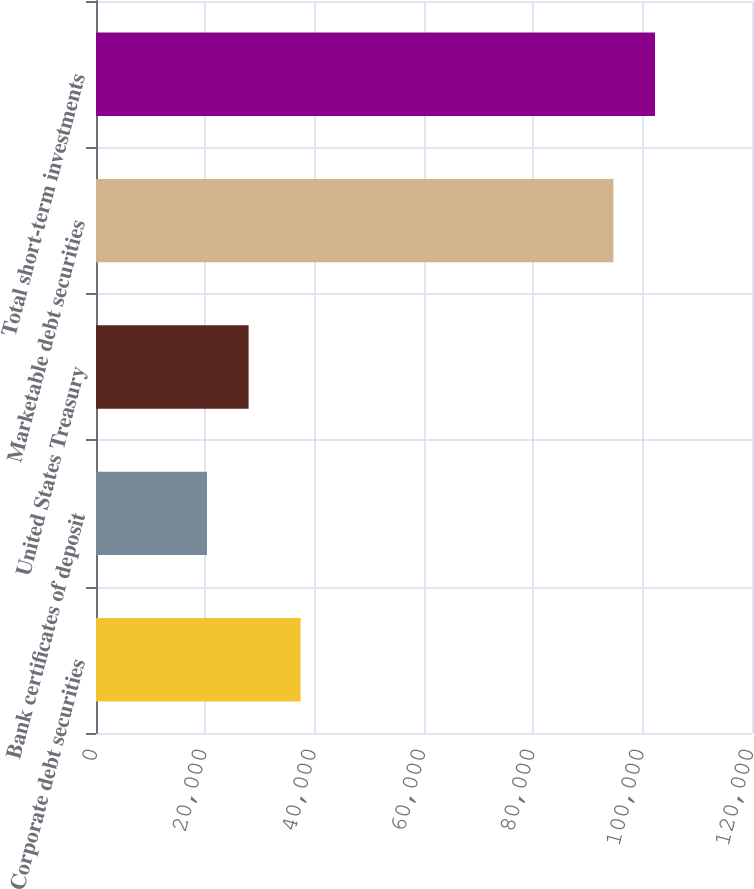Convert chart. <chart><loc_0><loc_0><loc_500><loc_500><bar_chart><fcel>Corporate debt securities<fcel>Bank certificates of deposit<fcel>United States Treasury<fcel>Marketable debt securities<fcel>Total short-term investments<nl><fcel>37422<fcel>20300<fcel>27916.2<fcel>94645<fcel>102261<nl></chart> 